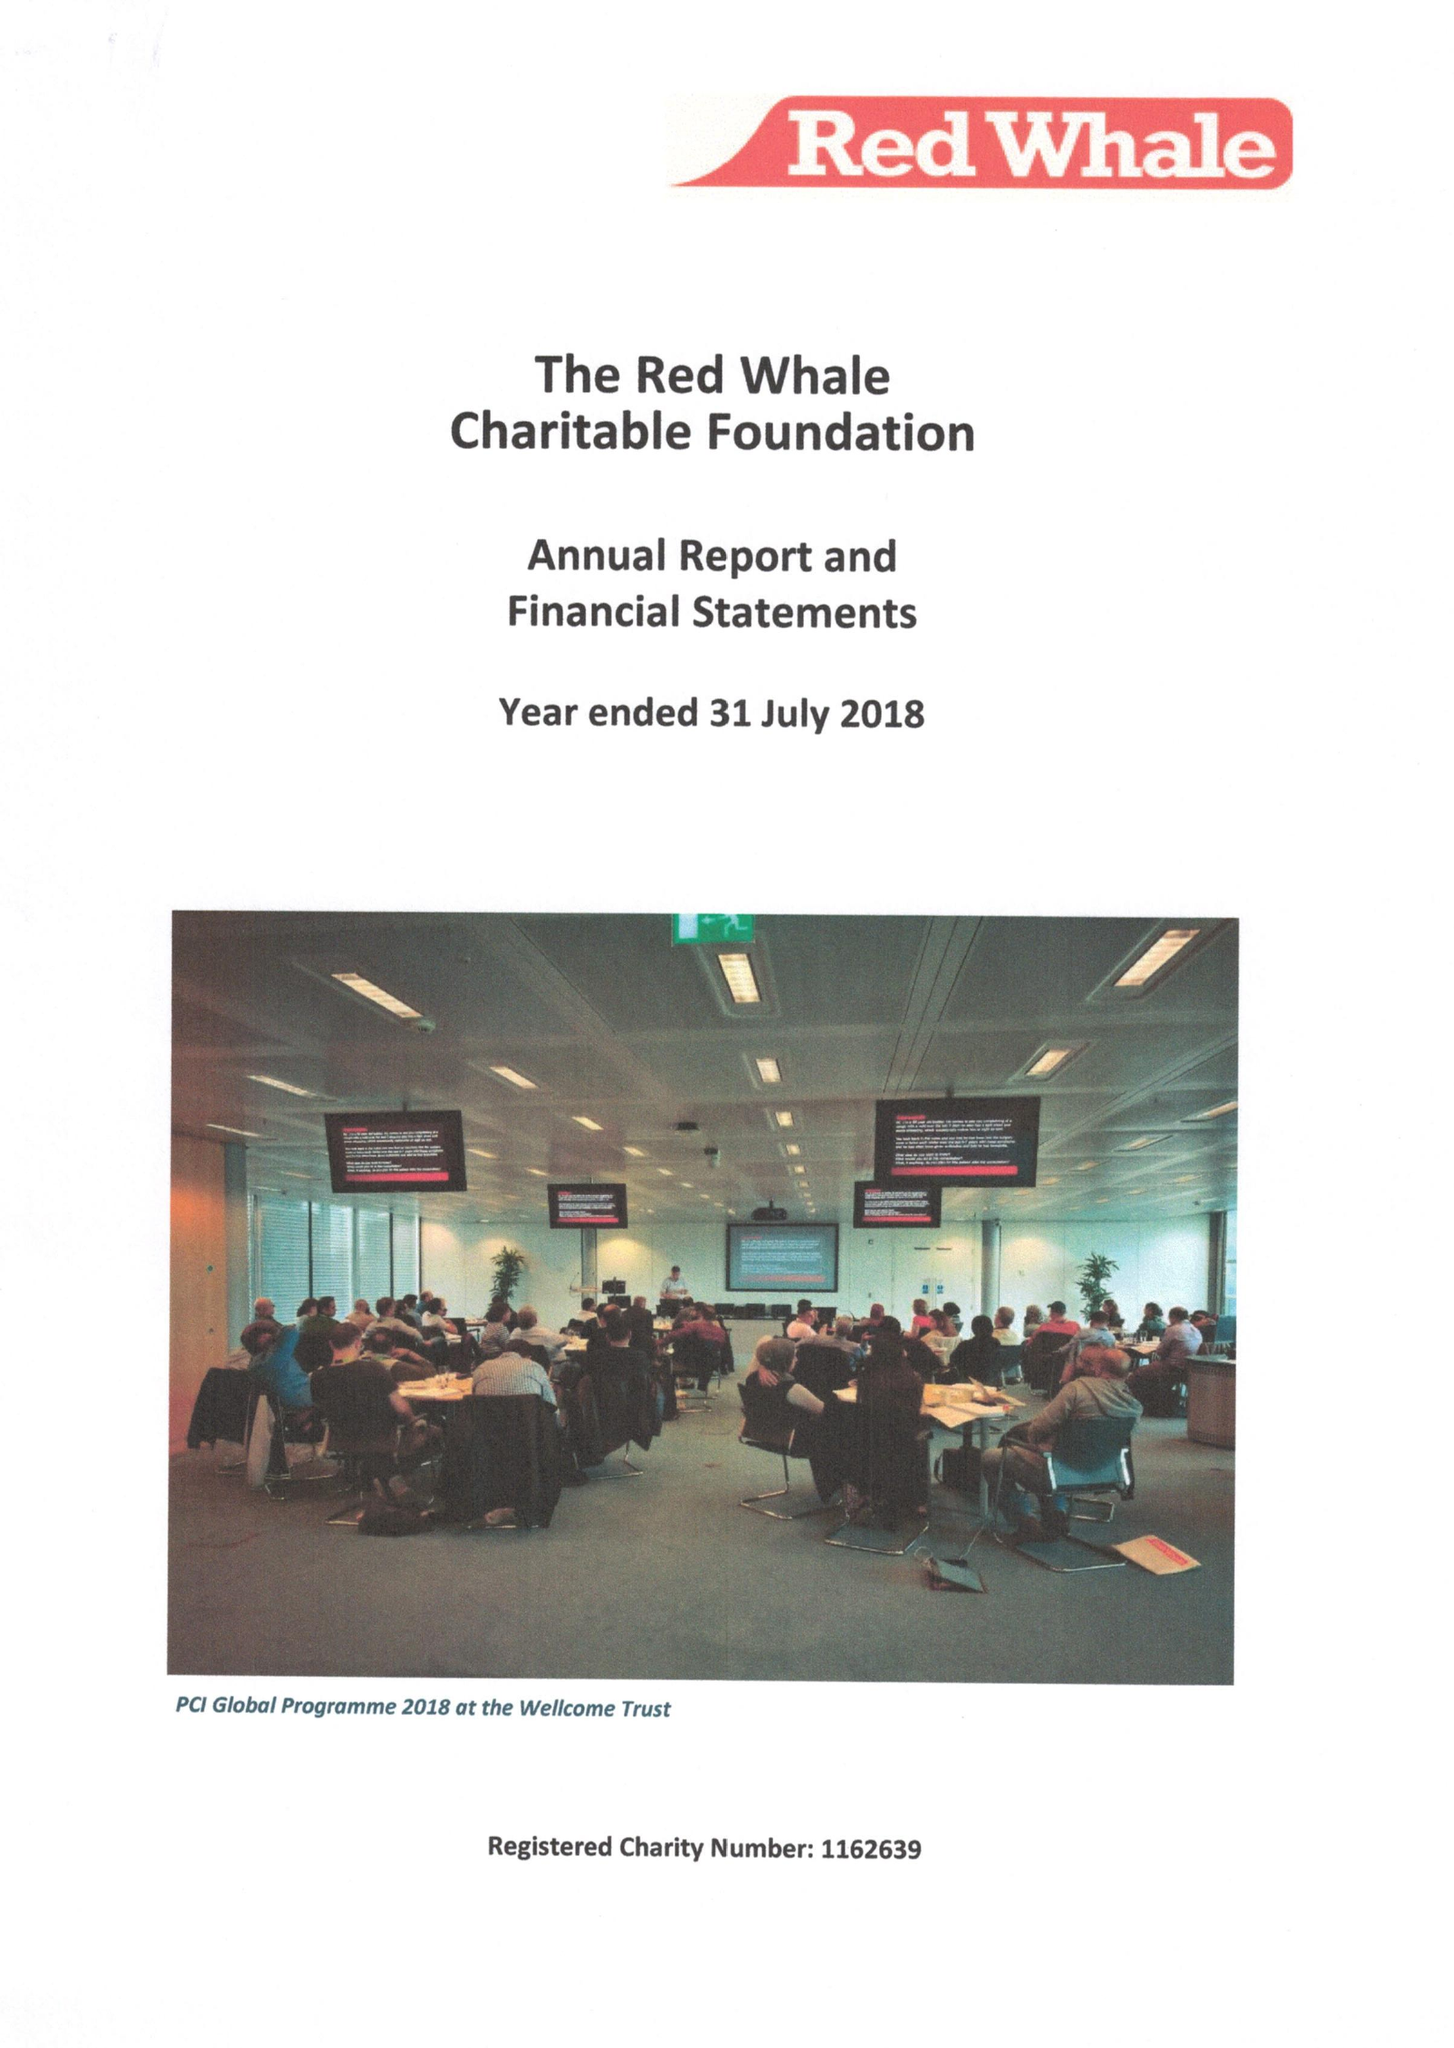What is the value for the charity_name?
Answer the question using a single word or phrase. The Red Whale Charitable Foundation 